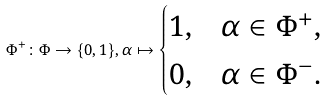<formula> <loc_0><loc_0><loc_500><loc_500>\Phi ^ { + } \colon \Phi \rightarrow \{ 0 , 1 \} , \alpha \mapsto \begin{cases} 1 , & \alpha \in \Phi ^ { + } , \\ 0 , & \alpha \in \Phi ^ { - } . \end{cases}</formula> 